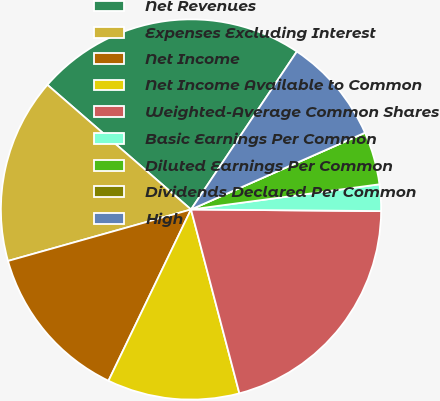Convert chart to OTSL. <chart><loc_0><loc_0><loc_500><loc_500><pie_chart><fcel>Net Revenues<fcel>Expenses Excluding Interest<fcel>Net Income<fcel>Net Income Available to Common<fcel>Weighted-Average Common Shares<fcel>Basic Earnings Per Common<fcel>Diluted Earnings Per Common<fcel>Dividends Declared Per Common<fcel>High<nl><fcel>23.02%<fcel>15.74%<fcel>13.49%<fcel>11.24%<fcel>20.77%<fcel>2.25%<fcel>4.5%<fcel>0.0%<fcel>8.99%<nl></chart> 